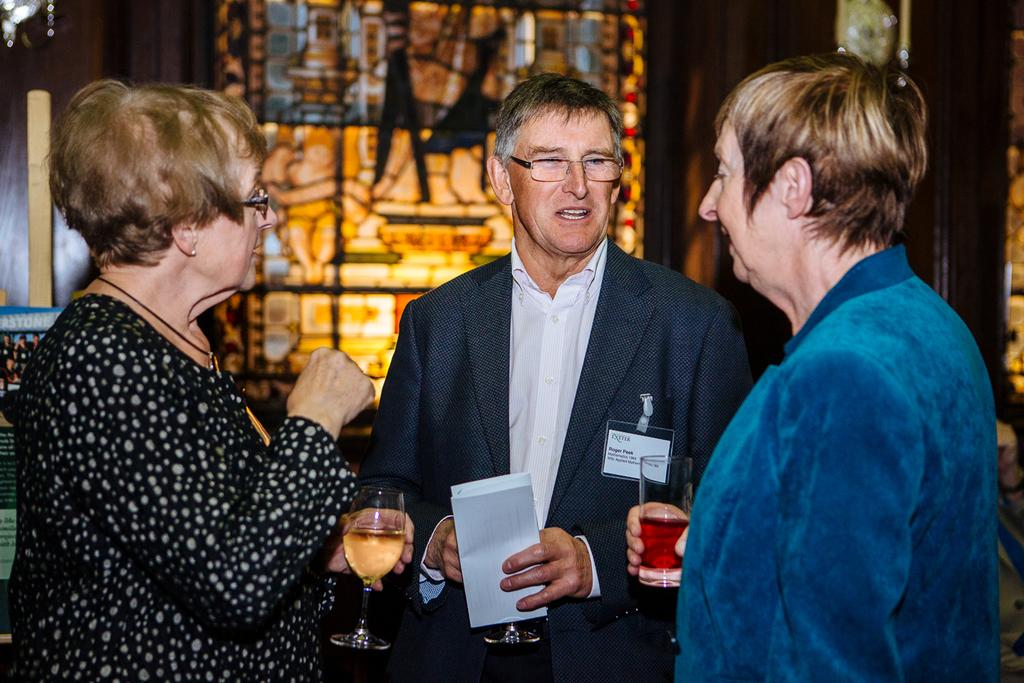How many people are in the center of the image? There are three members in the middle of the picture. What are the members holding in their hands? Each member is holding a glass in their hand. Can you describe the background of the image? The background of the image is blurred. What type of machine is being ordered by the members in the image? There is no machine or order present in the image; the members are simply holding glasses. 